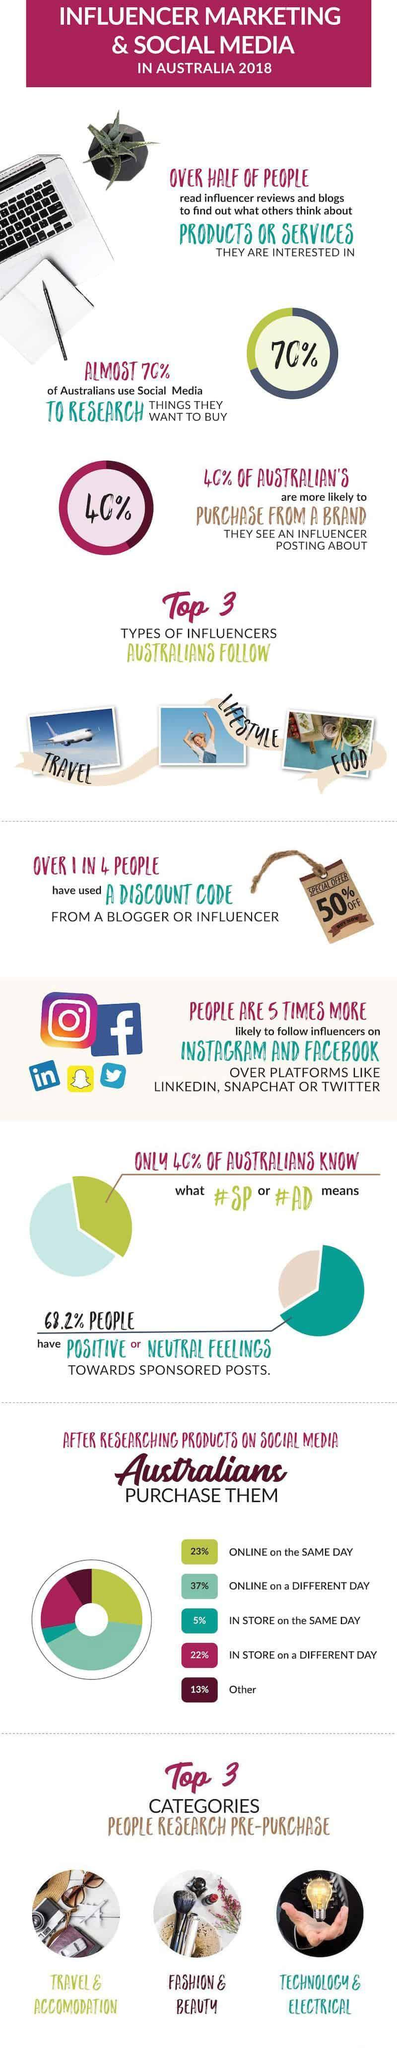What percentage of Australian's did not purchase from a brand that they see from an influencer's post?
Answer the question with a short phrase. 60% Which type of influencers Australians follow? Travel, lifestyle, food What is the percentage of online on the same day and online on a different day taken together? 60% What is the type of influencers other than travel and food in this infographic? lifestyle What percentage of people have a negative feeling towards sponsored posts? 31.8% What percentage of Australians did not know the meaning of #SP or #AD? 60% What percentage of Australians did not use social media to research things they want to buy? 30% Out of 4 people, how many people did not use a discount code from a blogger? 3 